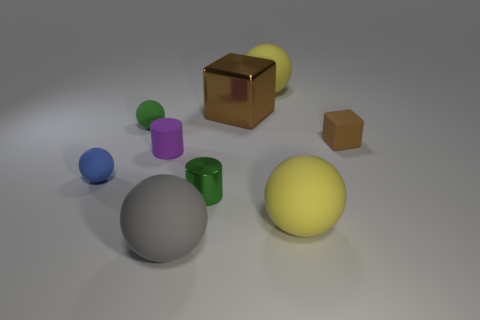What shape is the big shiny thing that is the same color as the tiny block?
Offer a terse response. Cube. There is a yellow rubber thing in front of the tiny green shiny object; is it the same shape as the green thing on the left side of the tiny purple cylinder?
Give a very brief answer. Yes. There is another thing that is the same shape as the small brown object; what material is it?
Your answer should be very brief. Metal. What color is the small thing that is to the right of the small green sphere and in front of the tiny purple object?
Give a very brief answer. Green. There is a cylinder on the right side of the tiny cylinder that is behind the blue ball; is there a large gray rubber ball behind it?
Ensure brevity in your answer.  No. How many things are small green things or small blue shiny blocks?
Your response must be concise. 2. Is the material of the small cube the same as the big thing behind the large block?
Your answer should be compact. Yes. Are there any other things that have the same color as the tiny shiny object?
Offer a terse response. Yes. How many objects are big matte objects that are behind the tiny rubber cube or small green things that are behind the small purple cylinder?
Your response must be concise. 2. There is a object that is both in front of the green ball and on the left side of the purple cylinder; what is its shape?
Your answer should be compact. Sphere. 